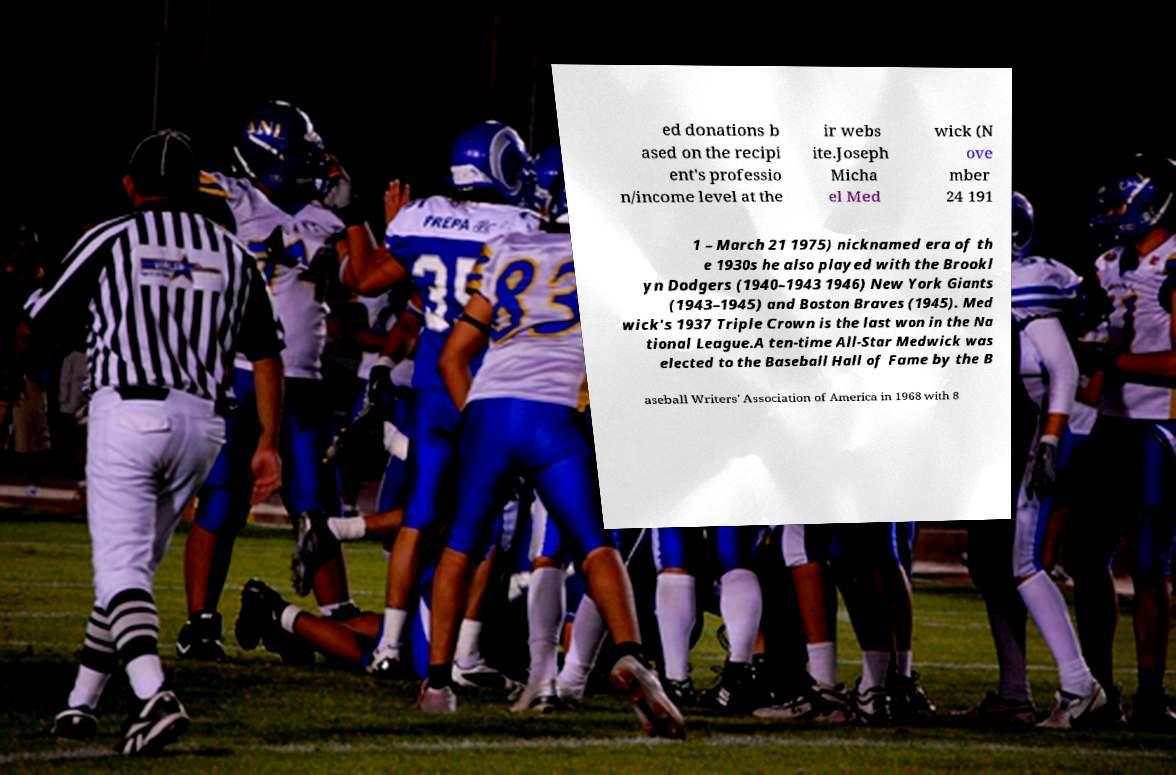Please identify and transcribe the text found in this image. ed donations b ased on the recipi ent's professio n/income level at the ir webs ite.Joseph Micha el Med wick (N ove mber 24 191 1 – March 21 1975) nicknamed era of th e 1930s he also played with the Brookl yn Dodgers (1940–1943 1946) New York Giants (1943–1945) and Boston Braves (1945). Med wick's 1937 Triple Crown is the last won in the Na tional League.A ten-time All-Star Medwick was elected to the Baseball Hall of Fame by the B aseball Writers' Association of America in 1968 with 8 